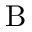Convert formula to latex. <formula><loc_0><loc_0><loc_500><loc_500>B</formula> 